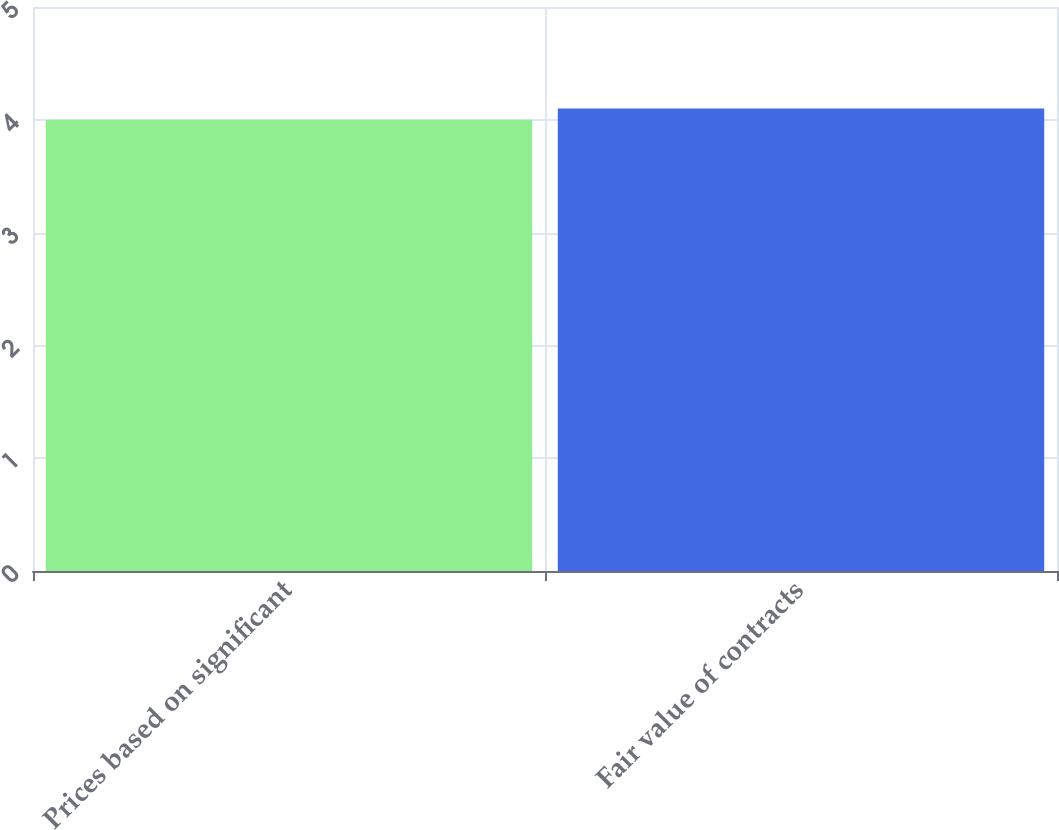Convert chart. <chart><loc_0><loc_0><loc_500><loc_500><bar_chart><fcel>Prices based on significant<fcel>Fair value of contracts<nl><fcel>4<fcel>4.1<nl></chart> 